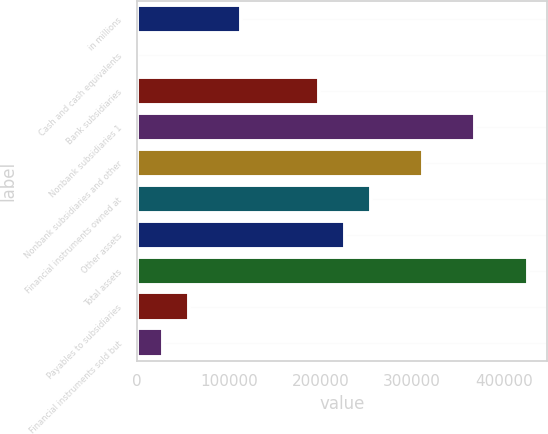Convert chart. <chart><loc_0><loc_0><loc_500><loc_500><bar_chart><fcel>in millions<fcel>Cash and cash equivalents<fcel>Bank subsidiaries<fcel>Nonbank subsidiaries 1<fcel>Nonbank subsidiaries and other<fcel>Financial instruments owned at<fcel>Other assets<fcel>Total assets<fcel>Payables to subsidiaries<fcel>Financial instruments sold but<nl><fcel>113575<fcel>14<fcel>198745<fcel>369087<fcel>312306<fcel>255526<fcel>227136<fcel>425867<fcel>56794.4<fcel>28404.2<nl></chart> 